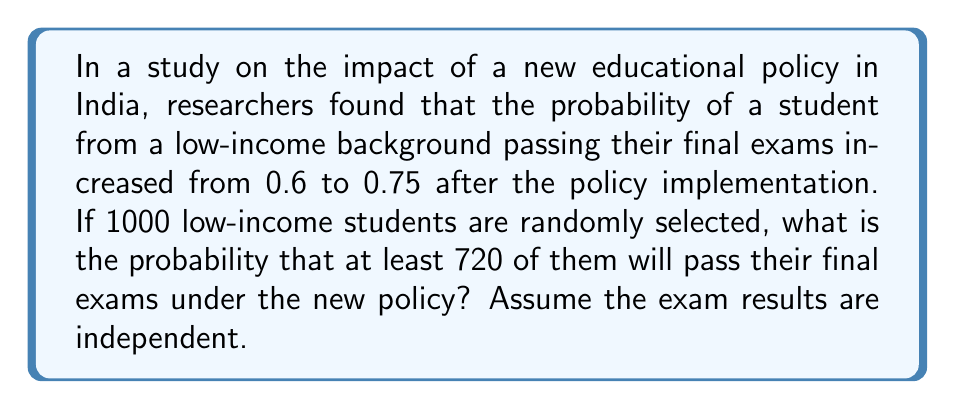Can you answer this question? Let's approach this step-by-step:

1) This is a binomial probability problem. We need to find $P(X \geq 720)$ where $X$ is the number of students passing the exam.

2) We have:
   $n = 1000$ (number of students)
   $p = 0.75$ (probability of passing under new policy)
   $k \geq 720$ (we want at least 720 students to pass)

3) The exact calculation would involve summing the binomial probabilities for $k = 720$ to $k = 1000$, which is computationally intensive. Instead, we can use the normal approximation to the binomial distribution.

4) For the normal approximation, we need the mean and standard deviation:
   $\mu = np = 1000 \times 0.75 = 750$
   $\sigma = \sqrt{np(1-p)} = \sqrt{1000 \times 0.75 \times 0.25} = \sqrt{187.5} \approx 13.69$

5) We need to find $P(X \geq 719.5)$ using the continuity correction. We calculate the z-score:

   $z = \frac{719.5 - 750}{13.69} \approx -2.23$

6) Now we need to find $P(Z > -2.23)$ where $Z$ is a standard normal variable.
   This is equivalent to $1 - P(Z < -2.23)$

7) Using a standard normal table or calculator:
   $P(Z < -2.23) \approx 0.0129$

8) Therefore, $P(X \geq 720) \approx 1 - 0.0129 = 0.9871$
Answer: 0.9871 